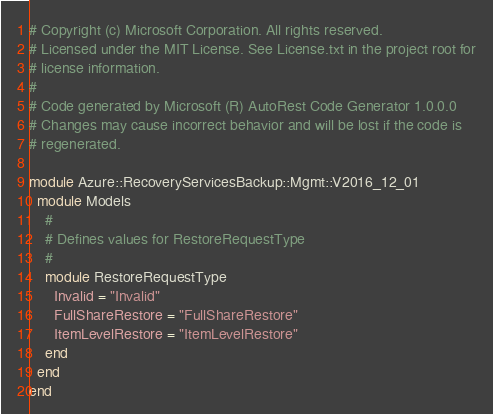<code> <loc_0><loc_0><loc_500><loc_500><_Ruby_># Copyright (c) Microsoft Corporation. All rights reserved.
# Licensed under the MIT License. See License.txt in the project root for
# license information.
#
# Code generated by Microsoft (R) AutoRest Code Generator 1.0.0.0
# Changes may cause incorrect behavior and will be lost if the code is
# regenerated.

module Azure::RecoveryServicesBackup::Mgmt::V2016_12_01
  module Models
    #
    # Defines values for RestoreRequestType
    #
    module RestoreRequestType
      Invalid = "Invalid"
      FullShareRestore = "FullShareRestore"
      ItemLevelRestore = "ItemLevelRestore"
    end
  end
end
</code> 